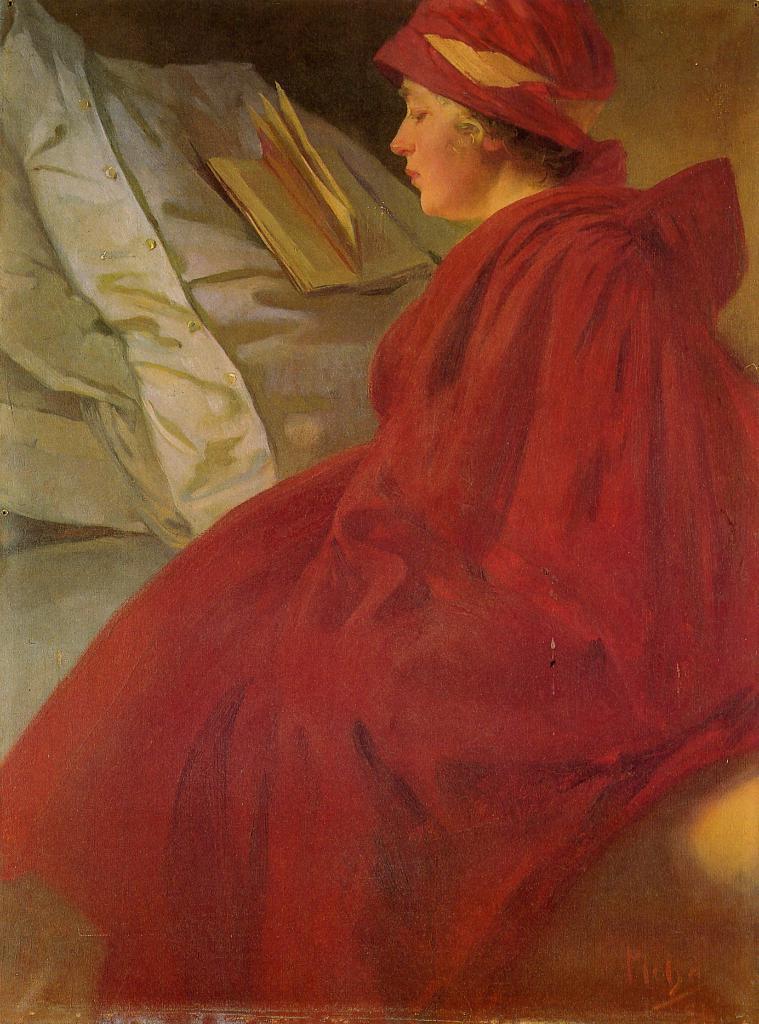Can you describe this image briefly? In this picture we can observe a woman sitting on the bed, wearing red color dress. There is a book placed on the bed. In the background there is a wall. 